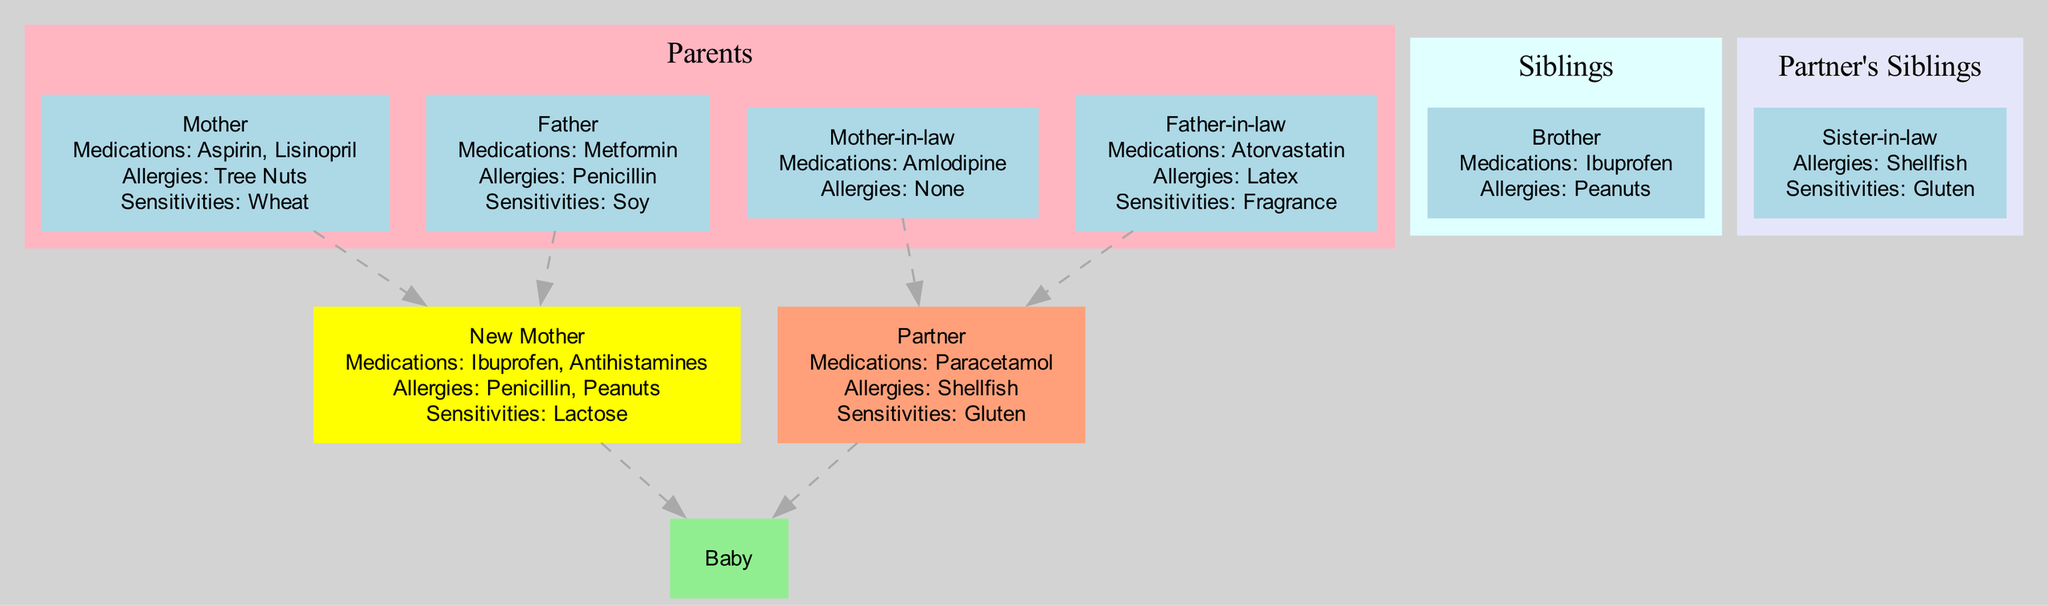What are the allergies of the new mother? The new mother's allergies are listed directly in her node within the diagram. Upon inspecting her node, I find that she has allergies to Penicillin and Peanuts.
Answer: Penicillin, Peanuts How many medications does the partner take? The partner's medications are indicated in his node. I can see that he takes one medication, which is Paracetamol. Thus, the total count is one.
Answer: 1 Who are the parents of the baby? The baby is a child of the 'Self' node and the 'Partner' node. By following the connecting edges from the baby to these two nodes, it's clear that they represent the baby's parents.
Answer: New Mother, Partner What is the sensitivity of the baby? The baby’s node specifies that there are no sensitivities present. Hence, I can conclude that the baby does not have any known sensitivities.
Answer: None Which sibling of the new mother has allergies? Among the new mother's siblings listed in the diagram, specifically the brother, I can check his node that shows his allergies. According to the node, he has an allergy to Peanuts.
Answer: Brother How many total allergies are listed among the parents? I need to examine each parent's node for their allergies. The mother has Tree Nuts, and the father has Penicillin allergies. By counting these unique allergies, I find there are two categories of allergies present in total.
Answer: 2 What medications does the mother-in-law take? The mother-in-law's node contains specific information regarding her medications. Upon reading her node, it's clear that the only medication she takes is Amlodipine.
Answer: Amlodipine Which family member has a sensitivity to gluten? To find the sensitivity to gluten, I check both the partner and sister-in-law nodes as gluten sensitivity is mentioned there. The sister-in-law's node states that she has a sensitivity to gluten, confirming her as the answer.
Answer: Sister-in-law What is the relationship between the new mother and the baby? The new mother node is directly connected to the baby node without any intervening nodes. This direct edge indicates a parent-child relationship. Thus, I conclude that the new mother is the baby's mother.
Answer: Mother 